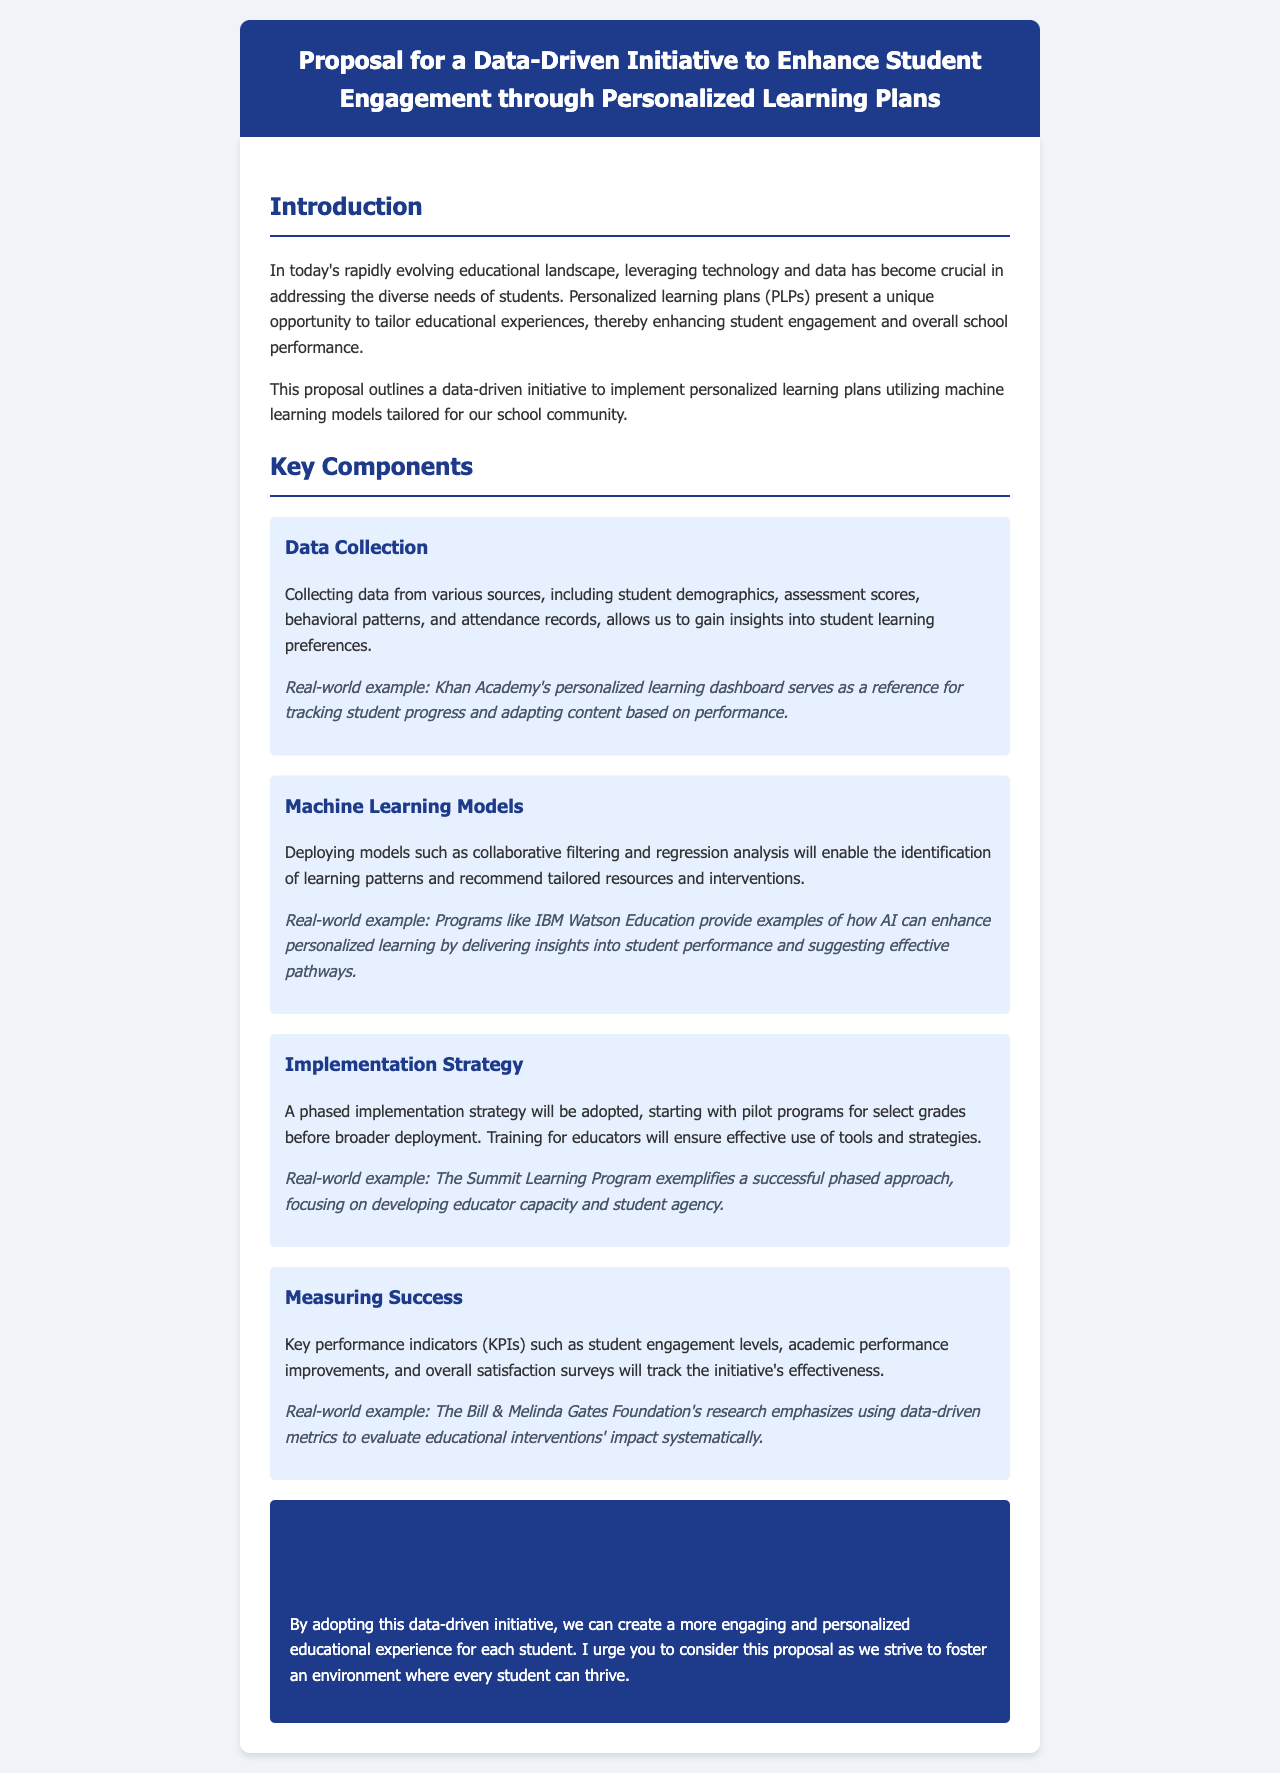What is the title of the proposal? The title of the proposal is stated in the document header.
Answer: Proposal for a Data-Driven Initiative to Enhance Student Engagement through Personalized Learning Plans What are the key components of the initiative? The document lists several key components that outline the framework of the initiative.
Answer: Data Collection, Machine Learning Models, Implementation Strategy, Measuring Success What machine learning models are mentioned in the proposal? The proposal describes specific machine learning models used for personalized learning.
Answer: Collaborative filtering and regression analysis What does the implementation strategy involve? The implementation strategy includes steps for deploying the initiative effectively in the school.
Answer: A phased implementation strategy Which foundation emphasizes using data-driven metrics? The document references an organization known for its research in education and data metrics.
Answer: Bill & Melinda Gates Foundation What example is used for data collection? The document includes a real-world example related to data collection methods for tracking progress.
Answer: Khan Academy's personalized learning dashboard What will be tracked to measure success? The proposal specifies key performance indicators indicative of the initiative's effectiveness.
Answer: Student engagement levels, academic performance improvements, overall satisfaction surveys Who is urged to consider the proposal? The concluding section of the proposal contains a call to action directed at a particular audience.
Answer: The audience (unspecified) 